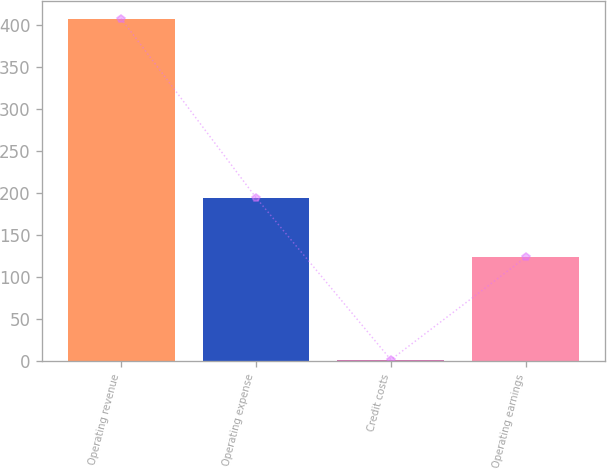Convert chart to OTSL. <chart><loc_0><loc_0><loc_500><loc_500><bar_chart><fcel>Operating revenue<fcel>Operating expense<fcel>Credit costs<fcel>Operating earnings<nl><fcel>408<fcel>195<fcel>2<fcel>124<nl></chart> 